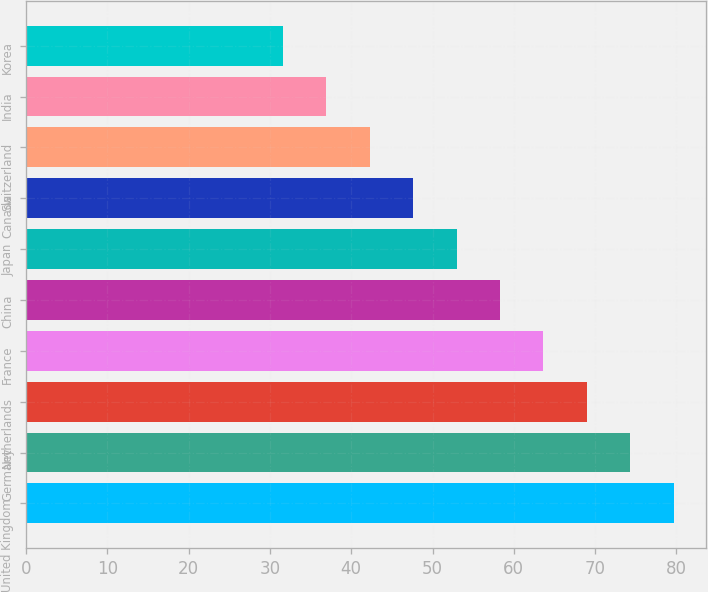Convert chart to OTSL. <chart><loc_0><loc_0><loc_500><loc_500><bar_chart><fcel>United Kingdom<fcel>Germany<fcel>Netherlands<fcel>France<fcel>China<fcel>Japan<fcel>Canada<fcel>Switzerland<fcel>India<fcel>Korea<nl><fcel>79.66<fcel>74.32<fcel>68.98<fcel>63.64<fcel>58.3<fcel>52.96<fcel>47.62<fcel>42.28<fcel>36.94<fcel>31.6<nl></chart> 